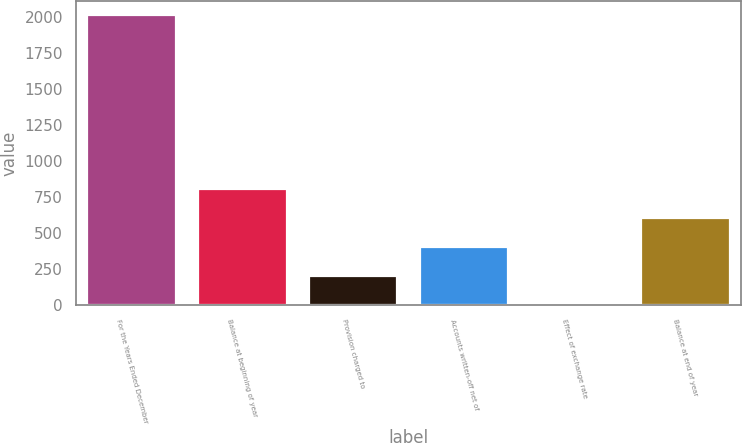<chart> <loc_0><loc_0><loc_500><loc_500><bar_chart><fcel>For the Years Ended December<fcel>Balance at beginning of year<fcel>Provision charged to<fcel>Accounts written-off net of<fcel>Effect of exchange rate<fcel>Balance at end of year<nl><fcel>2013<fcel>808.2<fcel>205.8<fcel>406.6<fcel>5<fcel>607.4<nl></chart> 